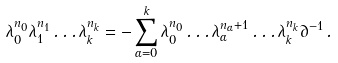<formula> <loc_0><loc_0><loc_500><loc_500>\lambda _ { 0 } ^ { n _ { 0 } } \lambda _ { 1 } ^ { n _ { 1 } } \dots \lambda _ { k } ^ { n _ { k } } = - \sum _ { \alpha = 0 } ^ { k } \lambda _ { 0 } ^ { n _ { 0 } } \dots \lambda _ { \alpha } ^ { n _ { \alpha } + 1 } \dots \lambda _ { k } ^ { n _ { k } } \partial ^ { - 1 } \, .</formula> 